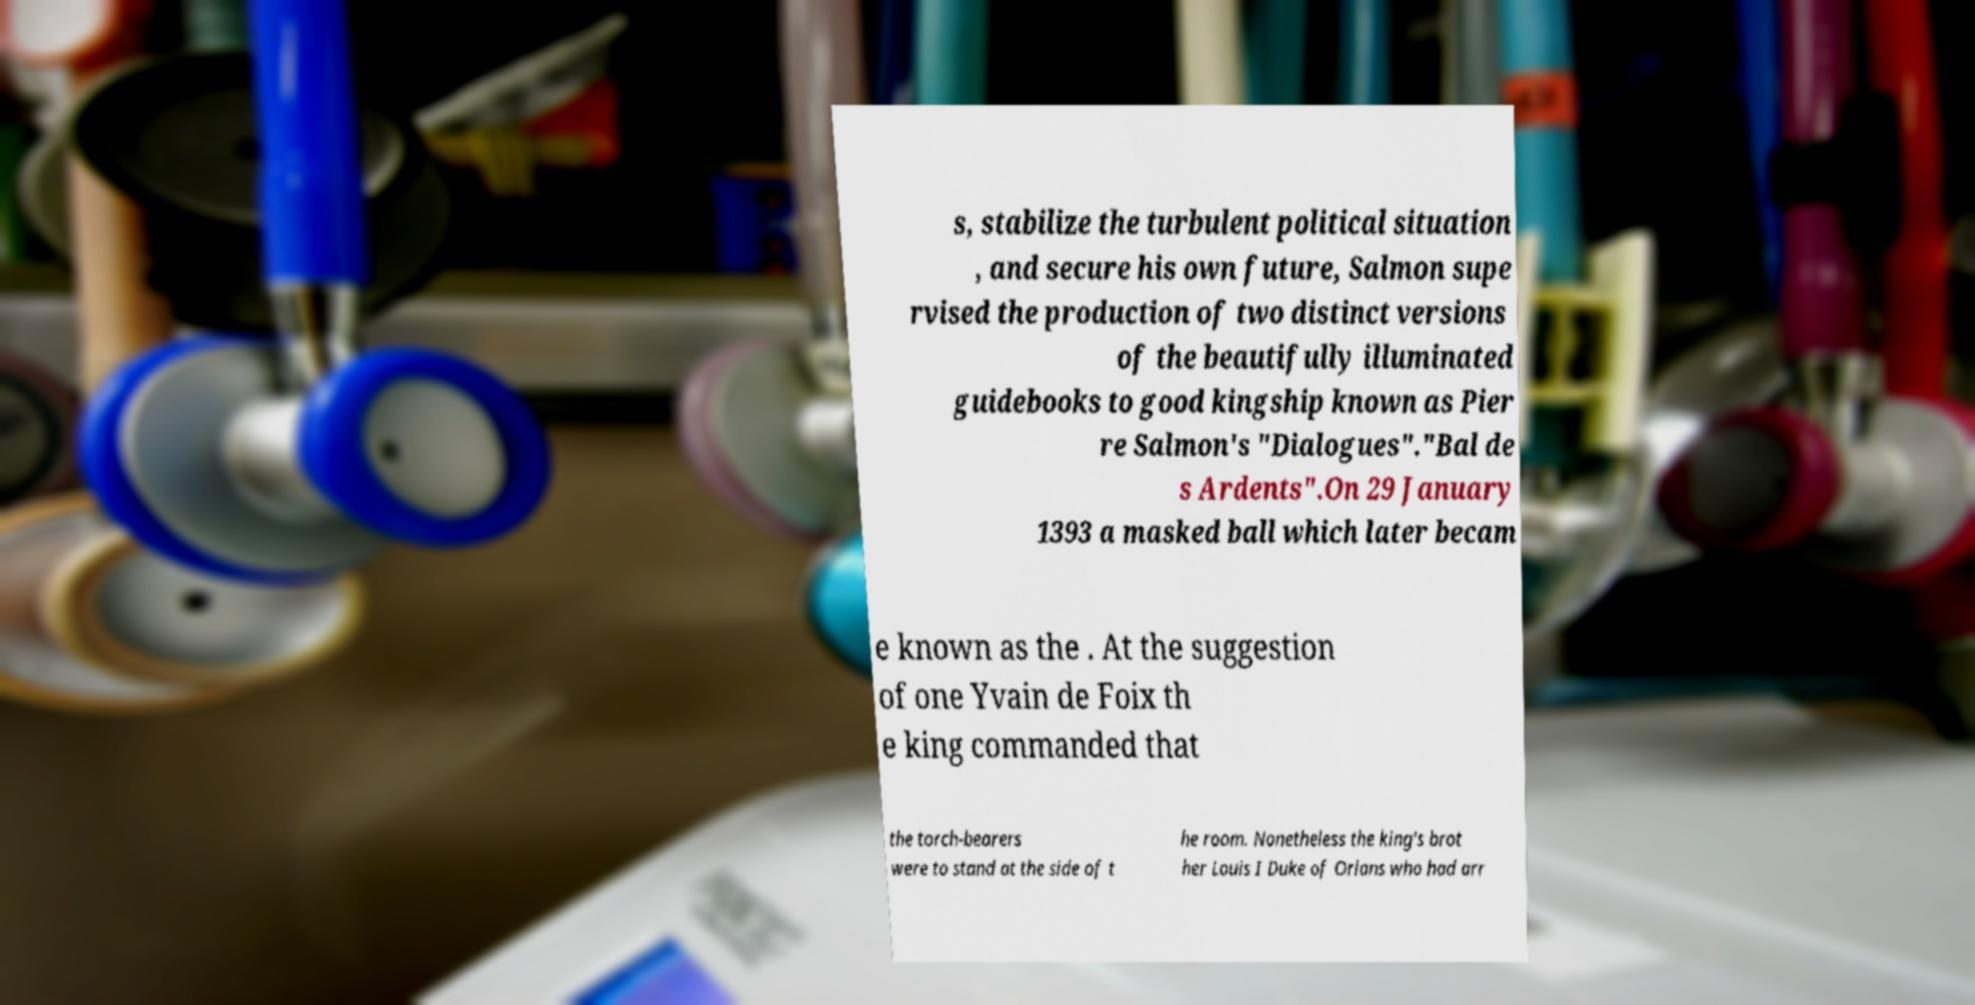Can you read and provide the text displayed in the image?This photo seems to have some interesting text. Can you extract and type it out for me? s, stabilize the turbulent political situation , and secure his own future, Salmon supe rvised the production of two distinct versions of the beautifully illuminated guidebooks to good kingship known as Pier re Salmon's "Dialogues"."Bal de s Ardents".On 29 January 1393 a masked ball which later becam e known as the . At the suggestion of one Yvain de Foix th e king commanded that the torch-bearers were to stand at the side of t he room. Nonetheless the king's brot her Louis I Duke of Orlans who had arr 